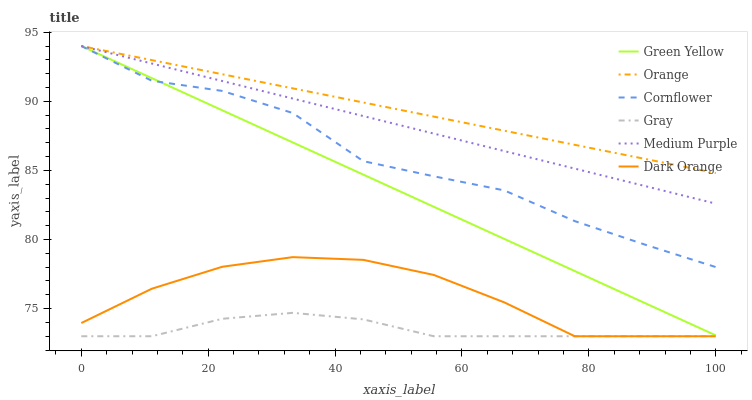Does Gray have the minimum area under the curve?
Answer yes or no. Yes. Does Orange have the maximum area under the curve?
Answer yes or no. Yes. Does Dark Orange have the minimum area under the curve?
Answer yes or no. No. Does Dark Orange have the maximum area under the curve?
Answer yes or no. No. Is Medium Purple the smoothest?
Answer yes or no. Yes. Is Cornflower the roughest?
Answer yes or no. Yes. Is Dark Orange the smoothest?
Answer yes or no. No. Is Dark Orange the roughest?
Answer yes or no. No. Does Medium Purple have the lowest value?
Answer yes or no. No. Does Dark Orange have the highest value?
Answer yes or no. No. Is Dark Orange less than Medium Purple?
Answer yes or no. Yes. Is Green Yellow greater than Gray?
Answer yes or no. Yes. Does Dark Orange intersect Medium Purple?
Answer yes or no. No. 